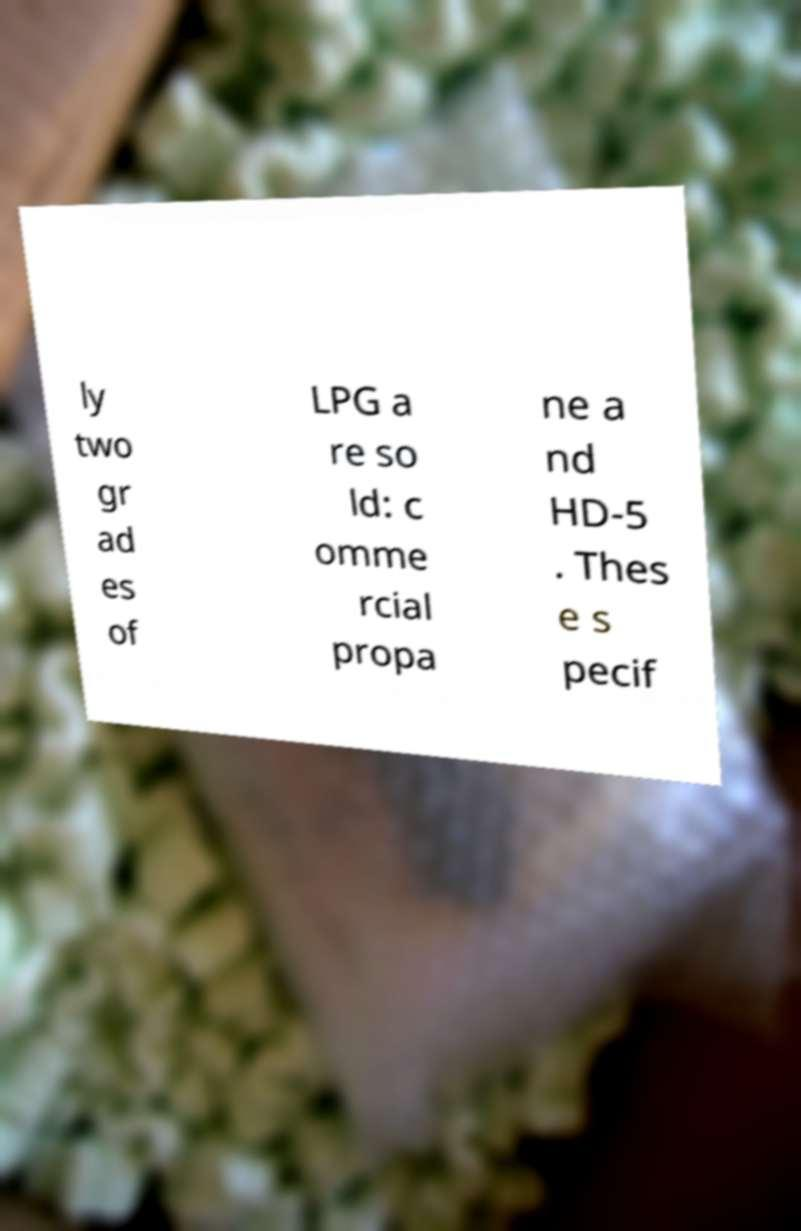For documentation purposes, I need the text within this image transcribed. Could you provide that? ly two gr ad es of LPG a re so ld: c omme rcial propa ne a nd HD-5 . Thes e s pecif 